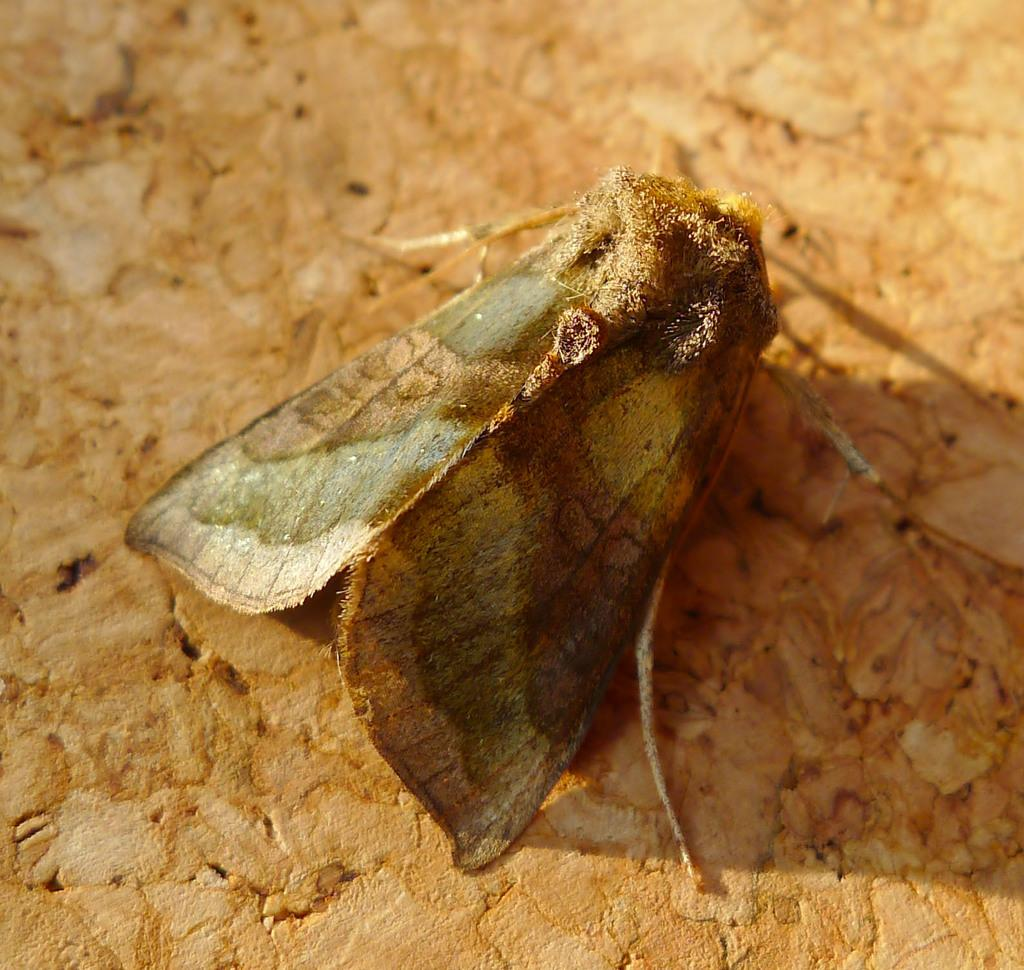What type of insect is in the image? There is a moth in the image. Where is the moth located? The moth is on a surface. What type of food is the moth eating in the image? There is no food present in the image, and the moth is not shown eating anything. 